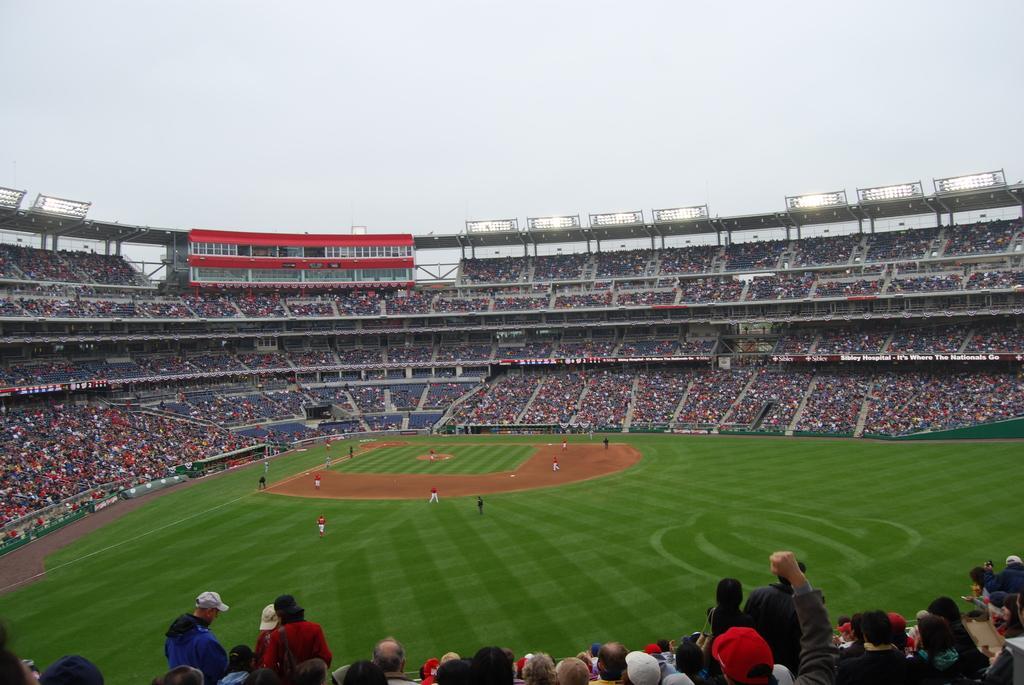How would you summarize this image in a sentence or two? In this image we can see many people on the ground. And there is a stadium. And we can see many people sitting. Some are wearing caps. And there are lights. In the background there is sky. 